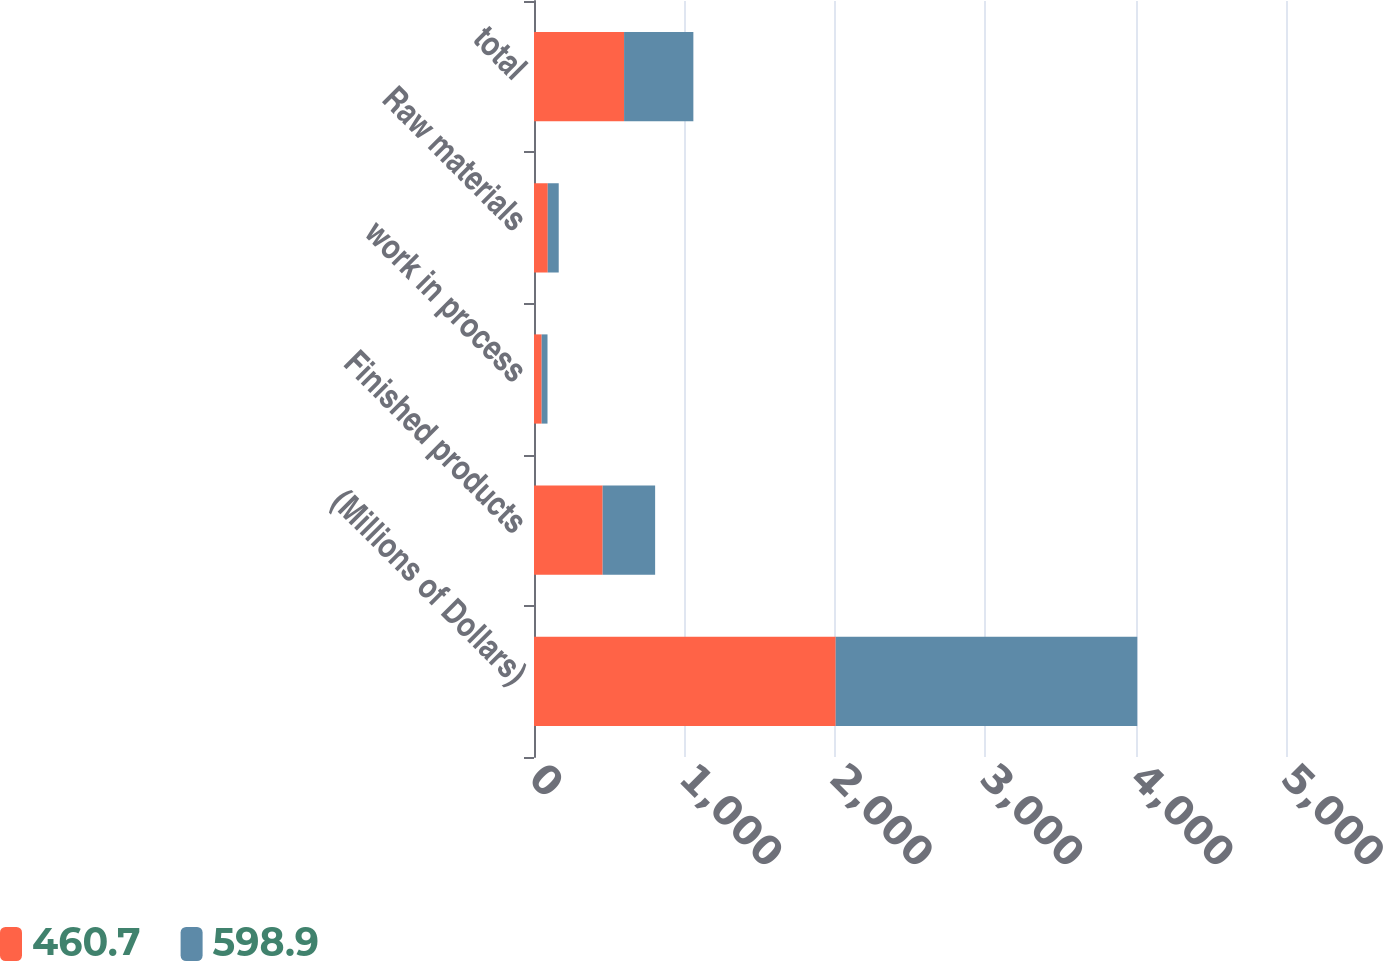Convert chart to OTSL. <chart><loc_0><loc_0><loc_500><loc_500><stacked_bar_chart><ecel><fcel>(Millions of Dollars)<fcel>Finished products<fcel>work in process<fcel>Raw materials<fcel>total<nl><fcel>460.7<fcel>2006<fcel>456.5<fcel>51<fcel>91.4<fcel>598.9<nl><fcel>598.9<fcel>2005<fcel>348.9<fcel>38.8<fcel>73<fcel>460.7<nl></chart> 